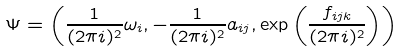Convert formula to latex. <formula><loc_0><loc_0><loc_500><loc_500>\Psi = \left ( \frac { 1 } { ( 2 \pi i ) ^ { 2 } } \omega _ { i } , - \frac { 1 } { ( 2 \pi i ) ^ { 2 } } a _ { i j } , \exp \left ( \frac { f _ { i j k } } { ( 2 \pi i ) ^ { 2 } } \right ) \right )</formula> 